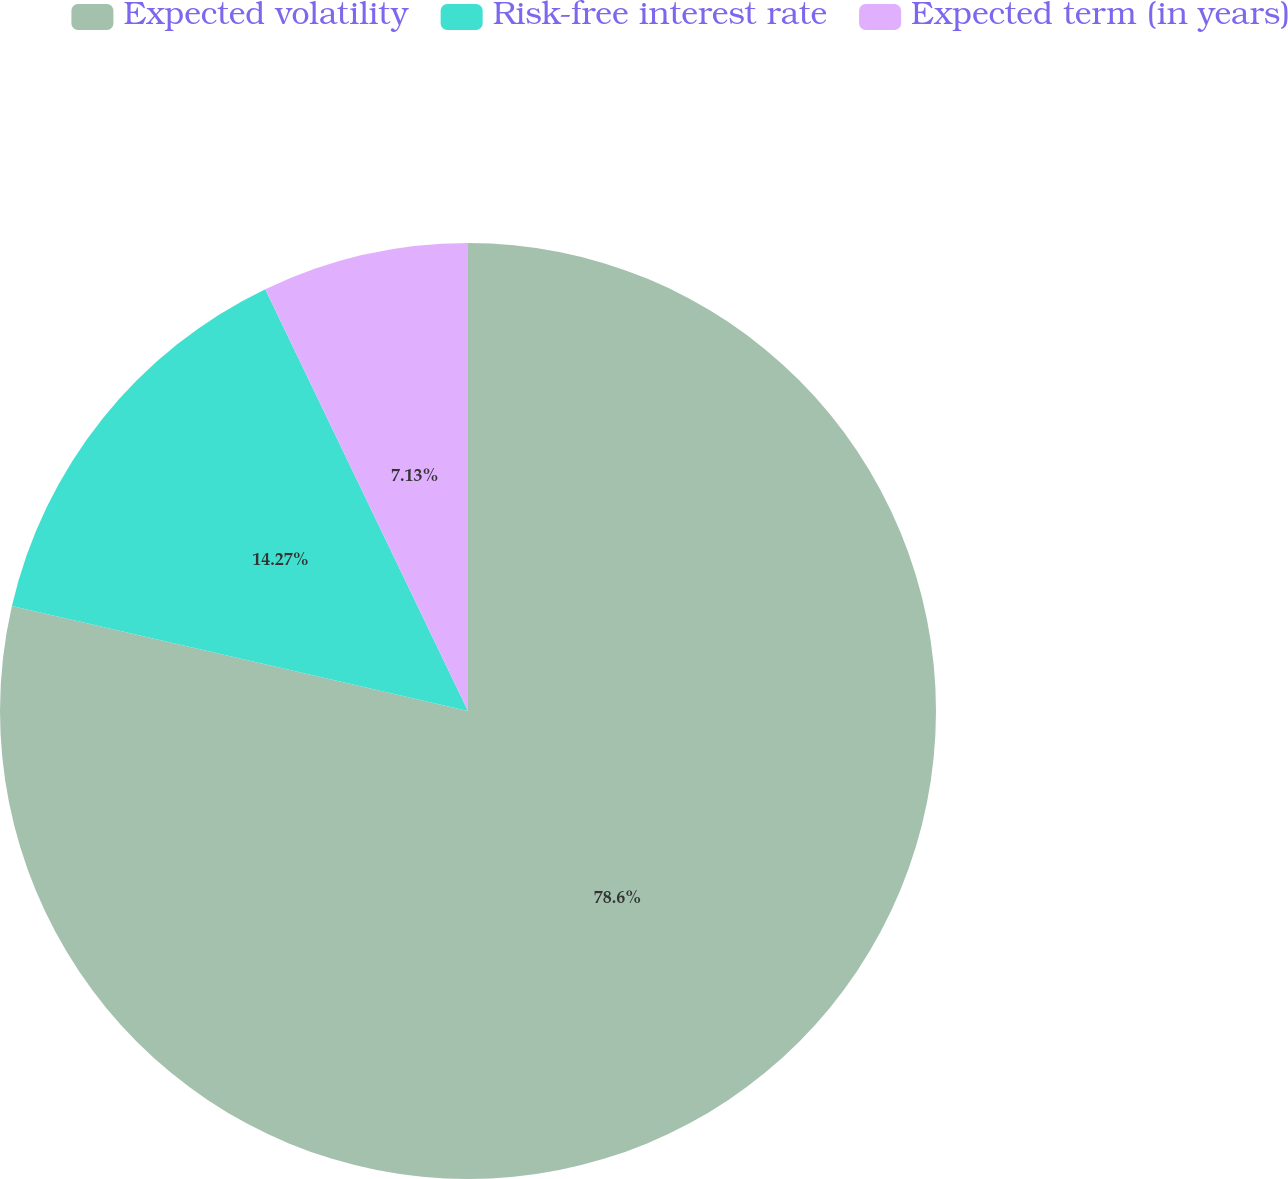<chart> <loc_0><loc_0><loc_500><loc_500><pie_chart><fcel>Expected volatility<fcel>Risk-free interest rate<fcel>Expected term (in years)<nl><fcel>78.6%<fcel>14.27%<fcel>7.13%<nl></chart> 